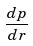<formula> <loc_0><loc_0><loc_500><loc_500>\frac { d p } { d r }</formula> 